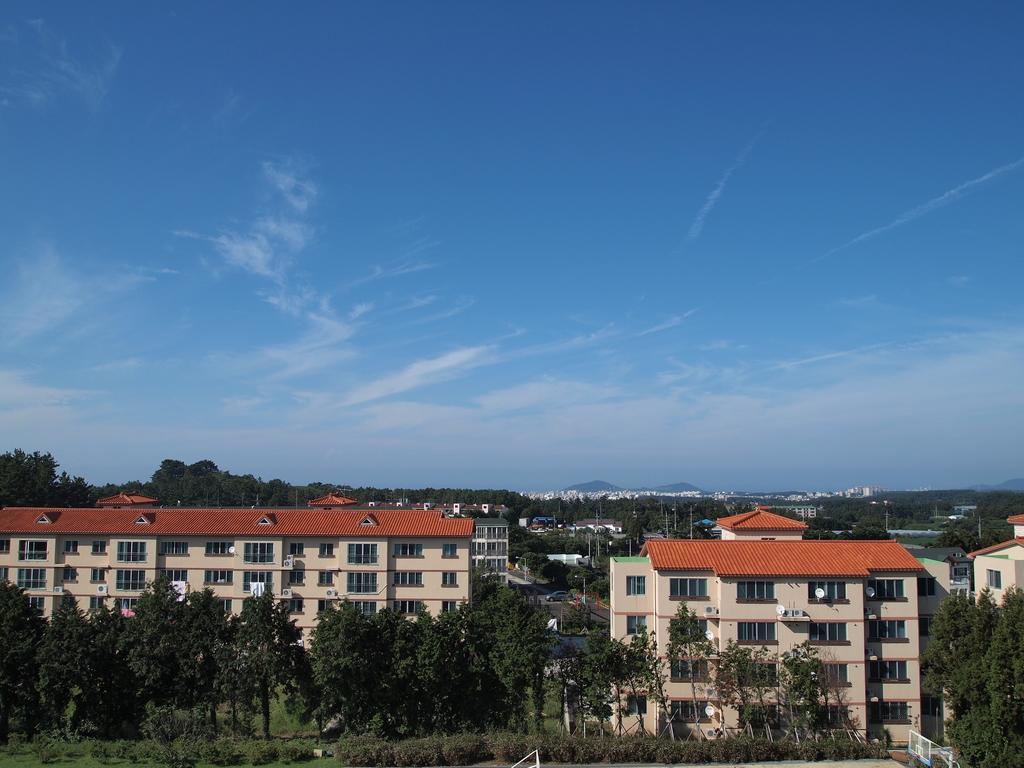Describe this image in one or two sentences. This is a view of a city. In this image we can see there are buildings, trees and sky. 